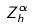<formula> <loc_0><loc_0><loc_500><loc_500>Z _ { h } ^ { \alpha }</formula> 